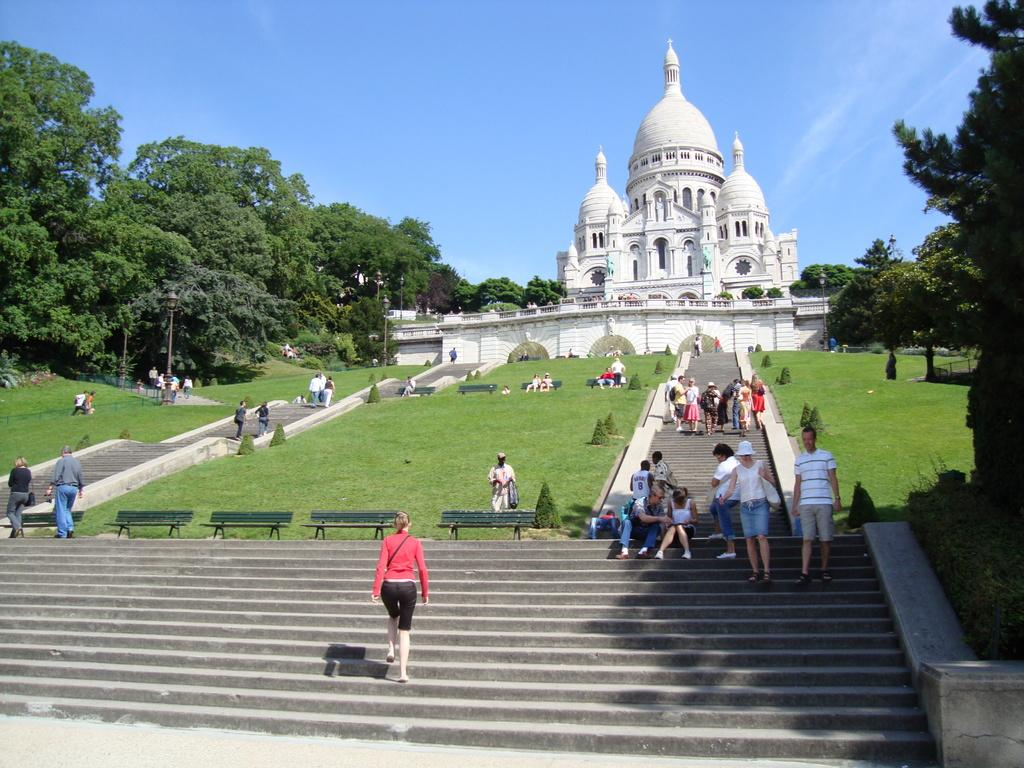How many people are in the image? There is a group of people in the image, but the exact number cannot be determined from the provided facts. What type of surface can be seen beneath the group of people? There is grass in the image, which suggests that the group of people is standing on a grassy area. What type of seating is available in the image? There are benches in the image, which can be used for sitting. What other types of vegetation are present in the image? There are plants and trees in the image, in addition to the grass. What structures are present in the image that are not part of the ancient architecture? There are poles and lights in the image, which may serve various purposes such as illumination or support. What can be seen in the background of the image? The sky is visible in the background of the image. What type of stone is used to create the wax sculptures in the image? There are no wax sculptures present in the image; it features a group of people, grass, benches, plants, trees, ancient architecture, poles, lights, and a visible sky. What do people believe about the ancient architecture in the image? The provided facts do not mention any beliefs or opinions about the ancient architecture, so it cannot be determined from the image. 